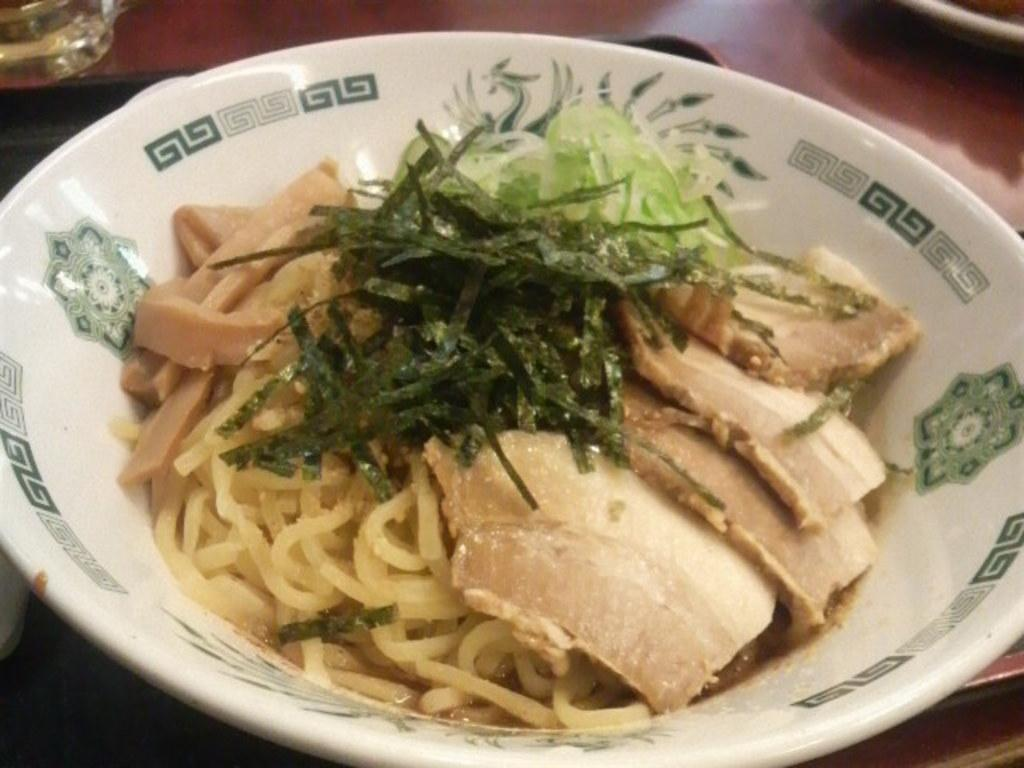What piece of furniture is present in the image? There is a table in the image. What is placed on the table? A glass and a tray are placed on the table. What is on the tray? There is a bowl on the tray. What is in the bowl? The bowl contains food items. What else can be found on the table besides the glass, tray, and bowl? There are other objects on the table. What degree of difficulty is the hook shown in the image? There is no hook present in the image. 